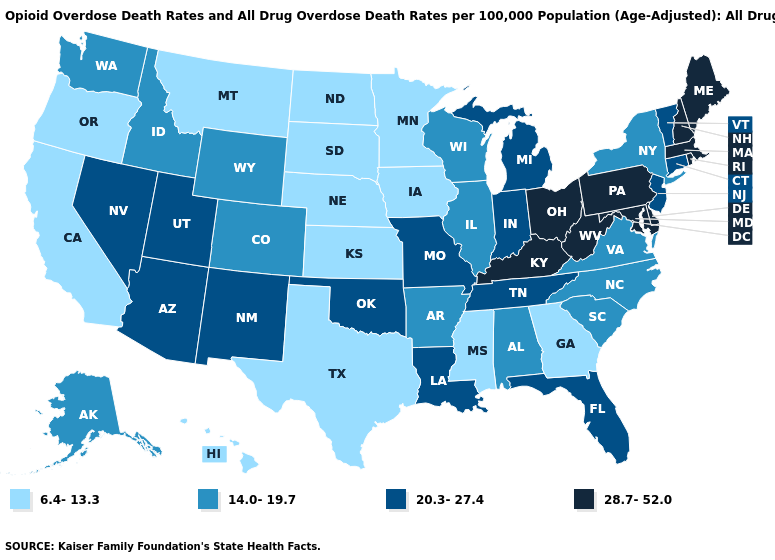Name the states that have a value in the range 28.7-52.0?
Answer briefly. Delaware, Kentucky, Maine, Maryland, Massachusetts, New Hampshire, Ohio, Pennsylvania, Rhode Island, West Virginia. Does New York have the highest value in the Northeast?
Concise answer only. No. Which states have the lowest value in the USA?
Concise answer only. California, Georgia, Hawaii, Iowa, Kansas, Minnesota, Mississippi, Montana, Nebraska, North Dakota, Oregon, South Dakota, Texas. Does the map have missing data?
Write a very short answer. No. Does Delaware have a higher value than New Hampshire?
Keep it brief. No. What is the value of Utah?
Short answer required. 20.3-27.4. Name the states that have a value in the range 14.0-19.7?
Keep it brief. Alabama, Alaska, Arkansas, Colorado, Idaho, Illinois, New York, North Carolina, South Carolina, Virginia, Washington, Wisconsin, Wyoming. What is the highest value in states that border Virginia?
Short answer required. 28.7-52.0. Name the states that have a value in the range 28.7-52.0?
Be succinct. Delaware, Kentucky, Maine, Maryland, Massachusetts, New Hampshire, Ohio, Pennsylvania, Rhode Island, West Virginia. How many symbols are there in the legend?
Keep it brief. 4. Name the states that have a value in the range 20.3-27.4?
Write a very short answer. Arizona, Connecticut, Florida, Indiana, Louisiana, Michigan, Missouri, Nevada, New Jersey, New Mexico, Oklahoma, Tennessee, Utah, Vermont. What is the value of Oklahoma?
Be succinct. 20.3-27.4. What is the value of Oregon?
Short answer required. 6.4-13.3. Does Arizona have the same value as Indiana?
Answer briefly. Yes. What is the value of Minnesota?
Give a very brief answer. 6.4-13.3. 